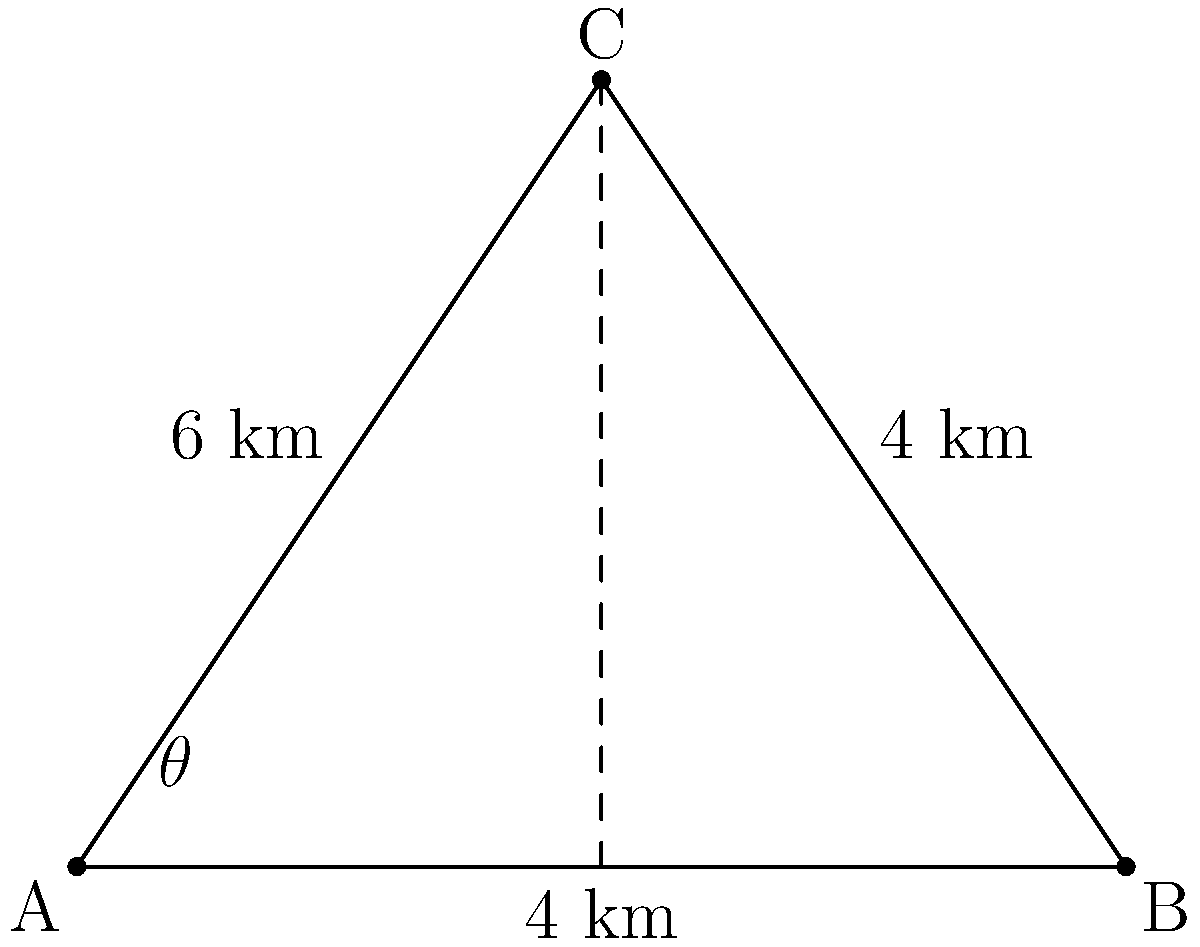As a policy analyst, you're tasked with optimizing the placement of wildlife cameras to monitor a rare species in a triangular reserve. The reserve is represented by triangle ABC, where AB = 8 km, BC = 4 km, and AC = 6 km. A camera placed at point C can cover an angle $\theta$ at A. Calculate the value of $\theta$ to determine the coverage area for the wildlife camera. To find the angle $\theta$, we can use the law of cosines:

1) In triangle ABC, we know all side lengths:
   AB = 8 km, BC = 4 km, AC = 6 km

2) The law of cosines states:
   $c^2 = a^2 + b^2 - 2ab \cos(C)$

3) In our case, we want to find angle A, so we rearrange the formula:
   $\cos(A) = \frac{b^2 + c^2 - a^2}{2bc}$

4) Substituting our values:
   $\cos(\theta) = \frac{8^2 + 6^2 - 4^2}{2 \cdot 8 \cdot 6}$

5) Simplify:
   $\cos(\theta) = \frac{64 + 36 - 16}{96} = \frac{84}{96} = \frac{7}{8}$

6) To find $\theta$, we take the inverse cosine (arccos):
   $\theta = \arccos(\frac{7}{8})$

7) Using a calculator or computer:
   $\theta \approx 0.5054 \text{ radians}$

8) Convert to degrees:
   $\theta \approx 28.96°$

Therefore, the camera at point C covers an angle of approximately 28.96° at point A.
Answer: $\theta \approx 28.96°$ 